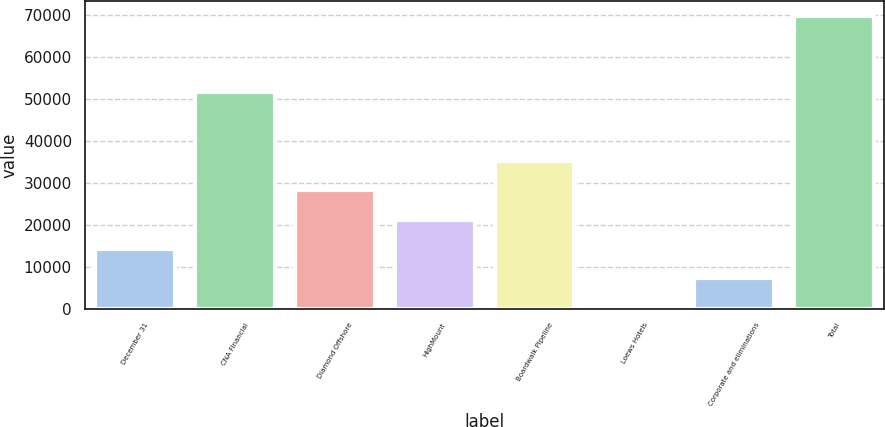Convert chart to OTSL. <chart><loc_0><loc_0><loc_500><loc_500><bar_chart><fcel>December 31<fcel>CNA Financial<fcel>Diamond Offshore<fcel>HighMount<fcel>Boardwalk Pipeline<fcel>Loews Hotels<fcel>Corporate and eliminations<fcel>Total<nl><fcel>14370.8<fcel>51624<fcel>28245.6<fcel>21308.2<fcel>35183<fcel>496<fcel>7433.4<fcel>69870<nl></chart> 